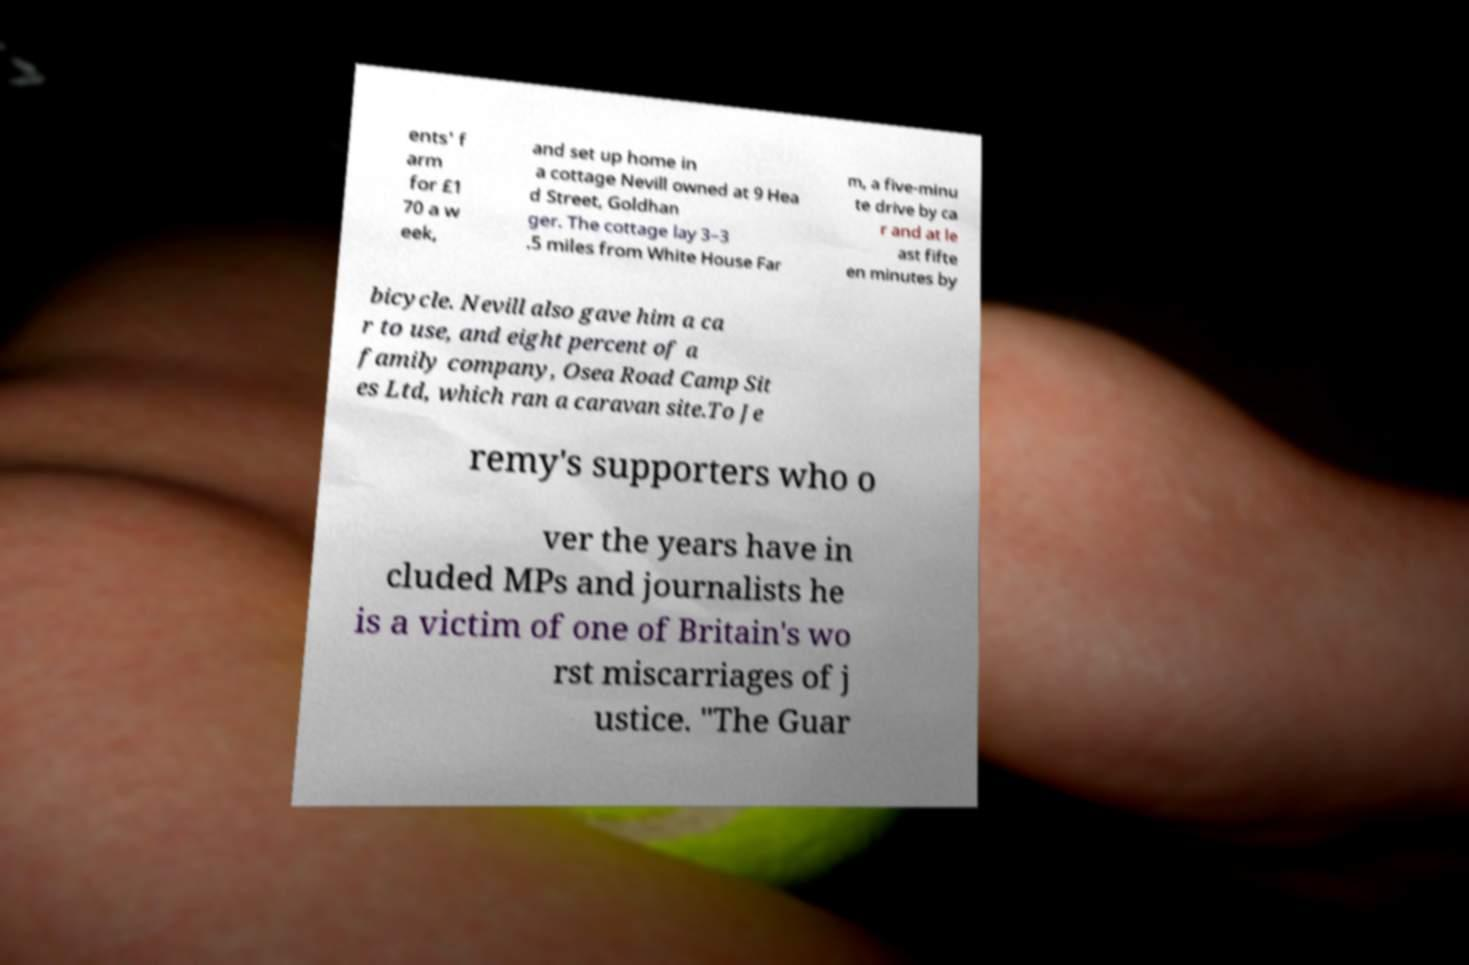Could you assist in decoding the text presented in this image and type it out clearly? ents' f arm for £1 70 a w eek, and set up home in a cottage Nevill owned at 9 Hea d Street, Goldhan ger. The cottage lay 3–3 .5 miles from White House Far m, a five-minu te drive by ca r and at le ast fifte en minutes by bicycle. Nevill also gave him a ca r to use, and eight percent of a family company, Osea Road Camp Sit es Ltd, which ran a caravan site.To Je remy's supporters who o ver the years have in cluded MPs and journalists he is a victim of one of Britain's wo rst miscarriages of j ustice. "The Guar 